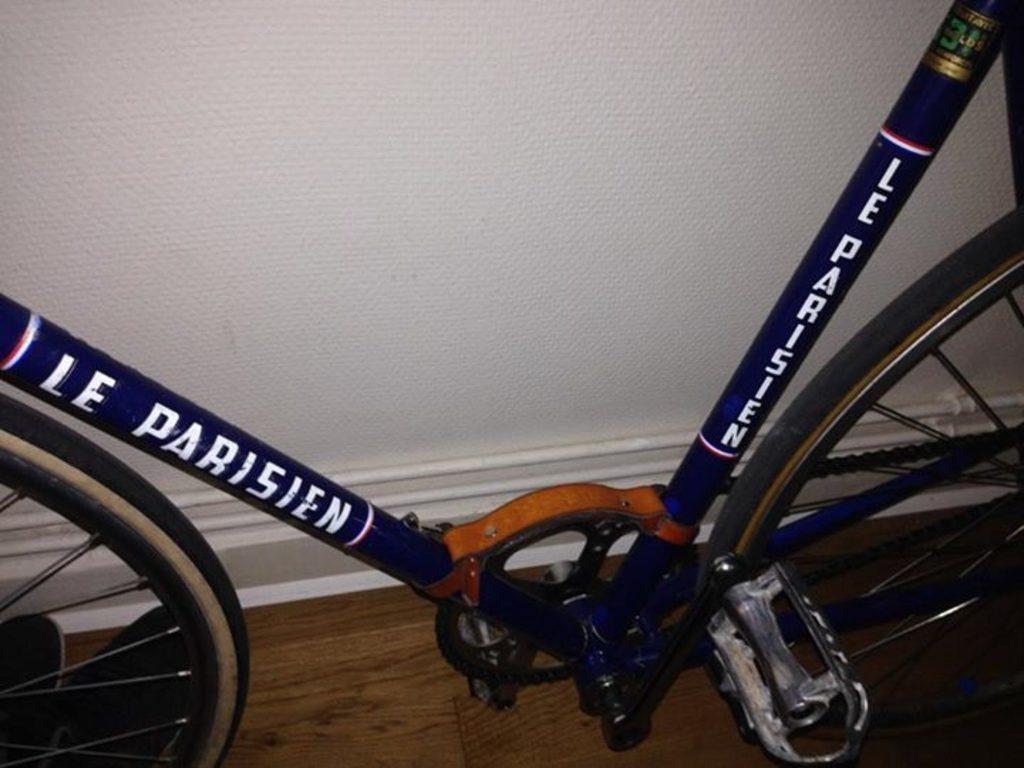Could you give a brief overview of what you see in this image? In the image the partial parts of a cycle are visible, behind the cycle there is a wall. 